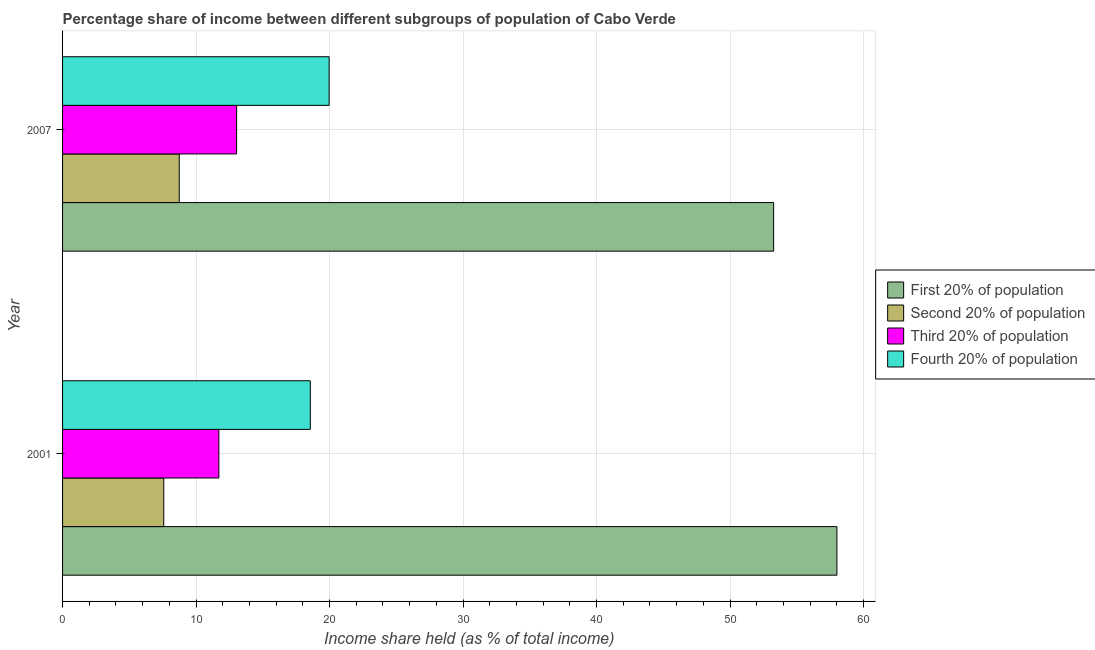How many different coloured bars are there?
Offer a very short reply. 4. How many bars are there on the 2nd tick from the top?
Your response must be concise. 4. How many bars are there on the 1st tick from the bottom?
Your answer should be very brief. 4. What is the share of the income held by fourth 20% of the population in 2001?
Offer a terse response. 18.56. Across all years, what is the maximum share of the income held by fourth 20% of the population?
Make the answer very short. 19.97. Across all years, what is the minimum share of the income held by fourth 20% of the population?
Your answer should be compact. 18.56. In which year was the share of the income held by second 20% of the population maximum?
Offer a terse response. 2007. In which year was the share of the income held by fourth 20% of the population minimum?
Provide a short and direct response. 2001. What is the total share of the income held by first 20% of the population in the graph?
Your answer should be compact. 111.28. What is the difference between the share of the income held by third 20% of the population in 2001 and that in 2007?
Ensure brevity in your answer.  -1.33. What is the difference between the share of the income held by fourth 20% of the population in 2007 and the share of the income held by third 20% of the population in 2001?
Offer a terse response. 8.26. What is the average share of the income held by first 20% of the population per year?
Give a very brief answer. 55.64. In the year 2007, what is the difference between the share of the income held by second 20% of the population and share of the income held by fourth 20% of the population?
Provide a short and direct response. -11.23. What is the ratio of the share of the income held by third 20% of the population in 2001 to that in 2007?
Make the answer very short. 0.9. Is it the case that in every year, the sum of the share of the income held by first 20% of the population and share of the income held by fourth 20% of the population is greater than the sum of share of the income held by third 20% of the population and share of the income held by second 20% of the population?
Offer a very short reply. Yes. What does the 4th bar from the top in 2007 represents?
Give a very brief answer. First 20% of population. What does the 3rd bar from the bottom in 2001 represents?
Give a very brief answer. Third 20% of population. Is it the case that in every year, the sum of the share of the income held by first 20% of the population and share of the income held by second 20% of the population is greater than the share of the income held by third 20% of the population?
Provide a succinct answer. Yes. Are all the bars in the graph horizontal?
Give a very brief answer. Yes. How many years are there in the graph?
Make the answer very short. 2. What is the difference between two consecutive major ticks on the X-axis?
Give a very brief answer. 10. Does the graph contain any zero values?
Offer a terse response. No. Does the graph contain grids?
Ensure brevity in your answer.  Yes. Where does the legend appear in the graph?
Provide a succinct answer. Center right. What is the title of the graph?
Your answer should be very brief. Percentage share of income between different subgroups of population of Cabo Verde. Does "Secondary vocational" appear as one of the legend labels in the graph?
Offer a terse response. No. What is the label or title of the X-axis?
Your answer should be compact. Income share held (as % of total income). What is the Income share held (as % of total income) in First 20% of population in 2001?
Make the answer very short. 58.01. What is the Income share held (as % of total income) of Second 20% of population in 2001?
Offer a very short reply. 7.58. What is the Income share held (as % of total income) in Third 20% of population in 2001?
Ensure brevity in your answer.  11.71. What is the Income share held (as % of total income) of Fourth 20% of population in 2001?
Make the answer very short. 18.56. What is the Income share held (as % of total income) in First 20% of population in 2007?
Ensure brevity in your answer.  53.27. What is the Income share held (as % of total income) of Second 20% of population in 2007?
Make the answer very short. 8.74. What is the Income share held (as % of total income) of Third 20% of population in 2007?
Give a very brief answer. 13.04. What is the Income share held (as % of total income) in Fourth 20% of population in 2007?
Provide a succinct answer. 19.97. Across all years, what is the maximum Income share held (as % of total income) of First 20% of population?
Offer a very short reply. 58.01. Across all years, what is the maximum Income share held (as % of total income) in Second 20% of population?
Offer a terse response. 8.74. Across all years, what is the maximum Income share held (as % of total income) of Third 20% of population?
Your answer should be very brief. 13.04. Across all years, what is the maximum Income share held (as % of total income) in Fourth 20% of population?
Provide a short and direct response. 19.97. Across all years, what is the minimum Income share held (as % of total income) in First 20% of population?
Ensure brevity in your answer.  53.27. Across all years, what is the minimum Income share held (as % of total income) of Second 20% of population?
Your answer should be compact. 7.58. Across all years, what is the minimum Income share held (as % of total income) in Third 20% of population?
Offer a terse response. 11.71. Across all years, what is the minimum Income share held (as % of total income) of Fourth 20% of population?
Make the answer very short. 18.56. What is the total Income share held (as % of total income) of First 20% of population in the graph?
Offer a terse response. 111.28. What is the total Income share held (as % of total income) in Second 20% of population in the graph?
Make the answer very short. 16.32. What is the total Income share held (as % of total income) in Third 20% of population in the graph?
Give a very brief answer. 24.75. What is the total Income share held (as % of total income) in Fourth 20% of population in the graph?
Keep it short and to the point. 38.53. What is the difference between the Income share held (as % of total income) of First 20% of population in 2001 and that in 2007?
Give a very brief answer. 4.74. What is the difference between the Income share held (as % of total income) of Second 20% of population in 2001 and that in 2007?
Give a very brief answer. -1.16. What is the difference between the Income share held (as % of total income) of Third 20% of population in 2001 and that in 2007?
Provide a succinct answer. -1.33. What is the difference between the Income share held (as % of total income) of Fourth 20% of population in 2001 and that in 2007?
Keep it short and to the point. -1.41. What is the difference between the Income share held (as % of total income) of First 20% of population in 2001 and the Income share held (as % of total income) of Second 20% of population in 2007?
Provide a succinct answer. 49.27. What is the difference between the Income share held (as % of total income) in First 20% of population in 2001 and the Income share held (as % of total income) in Third 20% of population in 2007?
Offer a terse response. 44.97. What is the difference between the Income share held (as % of total income) of First 20% of population in 2001 and the Income share held (as % of total income) of Fourth 20% of population in 2007?
Ensure brevity in your answer.  38.04. What is the difference between the Income share held (as % of total income) in Second 20% of population in 2001 and the Income share held (as % of total income) in Third 20% of population in 2007?
Provide a short and direct response. -5.46. What is the difference between the Income share held (as % of total income) of Second 20% of population in 2001 and the Income share held (as % of total income) of Fourth 20% of population in 2007?
Keep it short and to the point. -12.39. What is the difference between the Income share held (as % of total income) in Third 20% of population in 2001 and the Income share held (as % of total income) in Fourth 20% of population in 2007?
Your response must be concise. -8.26. What is the average Income share held (as % of total income) in First 20% of population per year?
Your response must be concise. 55.64. What is the average Income share held (as % of total income) of Second 20% of population per year?
Give a very brief answer. 8.16. What is the average Income share held (as % of total income) in Third 20% of population per year?
Your response must be concise. 12.38. What is the average Income share held (as % of total income) in Fourth 20% of population per year?
Your response must be concise. 19.27. In the year 2001, what is the difference between the Income share held (as % of total income) in First 20% of population and Income share held (as % of total income) in Second 20% of population?
Keep it short and to the point. 50.43. In the year 2001, what is the difference between the Income share held (as % of total income) of First 20% of population and Income share held (as % of total income) of Third 20% of population?
Offer a very short reply. 46.3. In the year 2001, what is the difference between the Income share held (as % of total income) of First 20% of population and Income share held (as % of total income) of Fourth 20% of population?
Provide a short and direct response. 39.45. In the year 2001, what is the difference between the Income share held (as % of total income) in Second 20% of population and Income share held (as % of total income) in Third 20% of population?
Make the answer very short. -4.13. In the year 2001, what is the difference between the Income share held (as % of total income) in Second 20% of population and Income share held (as % of total income) in Fourth 20% of population?
Provide a succinct answer. -10.98. In the year 2001, what is the difference between the Income share held (as % of total income) of Third 20% of population and Income share held (as % of total income) of Fourth 20% of population?
Provide a succinct answer. -6.85. In the year 2007, what is the difference between the Income share held (as % of total income) of First 20% of population and Income share held (as % of total income) of Second 20% of population?
Your answer should be compact. 44.53. In the year 2007, what is the difference between the Income share held (as % of total income) of First 20% of population and Income share held (as % of total income) of Third 20% of population?
Offer a very short reply. 40.23. In the year 2007, what is the difference between the Income share held (as % of total income) in First 20% of population and Income share held (as % of total income) in Fourth 20% of population?
Ensure brevity in your answer.  33.3. In the year 2007, what is the difference between the Income share held (as % of total income) of Second 20% of population and Income share held (as % of total income) of Fourth 20% of population?
Your response must be concise. -11.23. In the year 2007, what is the difference between the Income share held (as % of total income) in Third 20% of population and Income share held (as % of total income) in Fourth 20% of population?
Your answer should be very brief. -6.93. What is the ratio of the Income share held (as % of total income) of First 20% of population in 2001 to that in 2007?
Your answer should be compact. 1.09. What is the ratio of the Income share held (as % of total income) in Second 20% of population in 2001 to that in 2007?
Your answer should be compact. 0.87. What is the ratio of the Income share held (as % of total income) in Third 20% of population in 2001 to that in 2007?
Offer a very short reply. 0.9. What is the ratio of the Income share held (as % of total income) of Fourth 20% of population in 2001 to that in 2007?
Your response must be concise. 0.93. What is the difference between the highest and the second highest Income share held (as % of total income) of First 20% of population?
Ensure brevity in your answer.  4.74. What is the difference between the highest and the second highest Income share held (as % of total income) of Second 20% of population?
Give a very brief answer. 1.16. What is the difference between the highest and the second highest Income share held (as % of total income) in Third 20% of population?
Ensure brevity in your answer.  1.33. What is the difference between the highest and the second highest Income share held (as % of total income) of Fourth 20% of population?
Provide a short and direct response. 1.41. What is the difference between the highest and the lowest Income share held (as % of total income) of First 20% of population?
Provide a short and direct response. 4.74. What is the difference between the highest and the lowest Income share held (as % of total income) in Second 20% of population?
Provide a short and direct response. 1.16. What is the difference between the highest and the lowest Income share held (as % of total income) in Third 20% of population?
Give a very brief answer. 1.33. What is the difference between the highest and the lowest Income share held (as % of total income) of Fourth 20% of population?
Your answer should be compact. 1.41. 